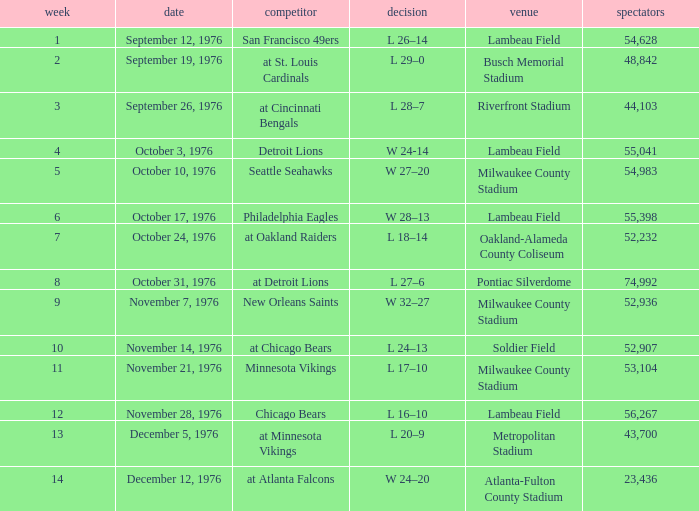What is the lowest week number where they played against the Detroit Lions? 4.0. 